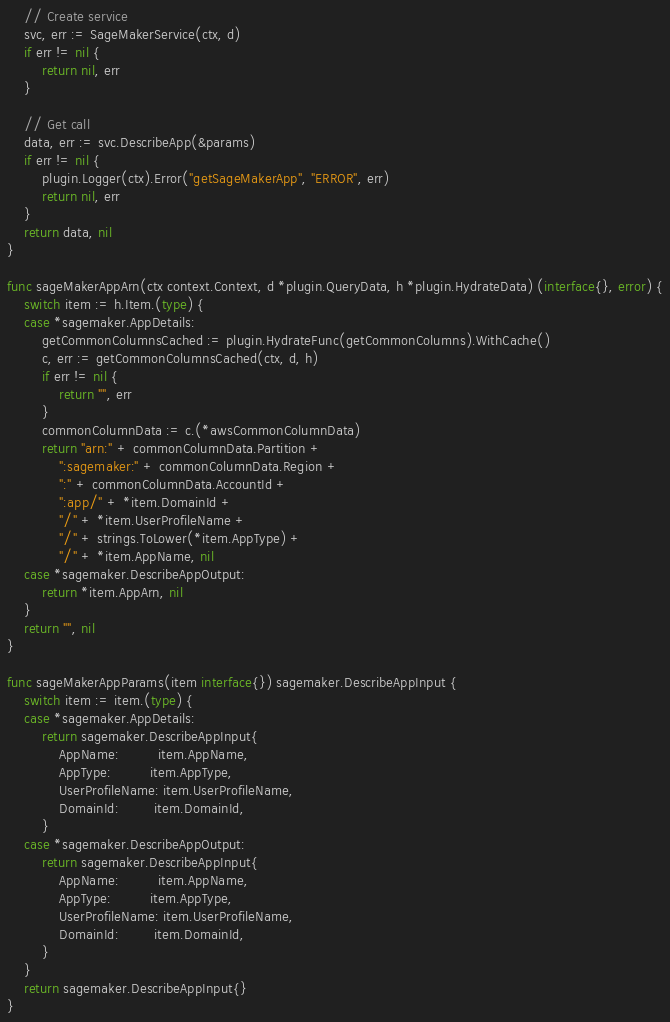Convert code to text. <code><loc_0><loc_0><loc_500><loc_500><_Go_>	// Create service
	svc, err := SageMakerService(ctx, d)
	if err != nil {
		return nil, err
	}

	// Get call
	data, err := svc.DescribeApp(&params)
	if err != nil {
		plugin.Logger(ctx).Error("getSageMakerApp", "ERROR", err)
		return nil, err
	}
	return data, nil
}

func sageMakerAppArn(ctx context.Context, d *plugin.QueryData, h *plugin.HydrateData) (interface{}, error) {
	switch item := h.Item.(type) {
	case *sagemaker.AppDetails:
		getCommonColumnsCached := plugin.HydrateFunc(getCommonColumns).WithCache()
		c, err := getCommonColumnsCached(ctx, d, h)
		if err != nil {
			return "", err
		}
		commonColumnData := c.(*awsCommonColumnData)
		return "arn:" + commonColumnData.Partition +
			":sagemaker:" + commonColumnData.Region +
			":" + commonColumnData.AccountId +
			":app/" + *item.DomainId +
			"/" + *item.UserProfileName +
			"/" + strings.ToLower(*item.AppType) +
			"/" + *item.AppName, nil
	case *sagemaker.DescribeAppOutput:
		return *item.AppArn, nil
	}
	return "", nil
}

func sageMakerAppParams(item interface{}) sagemaker.DescribeAppInput {
	switch item := item.(type) {
	case *sagemaker.AppDetails:
		return sagemaker.DescribeAppInput{
			AppName:         item.AppName,
			AppType:         item.AppType,
			UserProfileName: item.UserProfileName,
			DomainId:        item.DomainId,
		}
	case *sagemaker.DescribeAppOutput:
		return sagemaker.DescribeAppInput{
			AppName:         item.AppName,
			AppType:         item.AppType,
			UserProfileName: item.UserProfileName,
			DomainId:        item.DomainId,
		}
	}
	return sagemaker.DescribeAppInput{}
}
</code> 